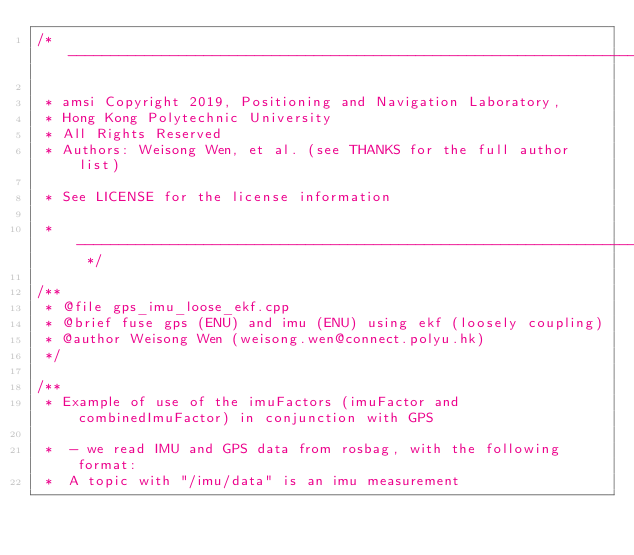<code> <loc_0><loc_0><loc_500><loc_500><_C++_>/* ----------------------------------------------------------------------------

 * amsi Copyright 2019, Positioning and Navigation Laboratory,
 * Hong Kong Polytechnic University
 * All Rights Reserved
 * Authors: Weisong Wen, et al. (see THANKS for the full author list)

 * See LICENSE for the license information

 * -------------------------------------------------------------------------- */

/**
 * @file gps_imu_loose_ekf.cpp
 * @brief fuse gps (ENU) and imu (ENU) using ekf (loosely coupling)
 * @author Weisong Wen (weisong.wen@connect.polyu.hk)
 */

/**
 * Example of use of the imuFactors (imuFactor and combinedImuFactor) in conjunction with GPS
 
 *  - we read IMU and GPS data from rosbag, with the following format:
 *  A topic with "/imu/data" is an imu measurement</code> 